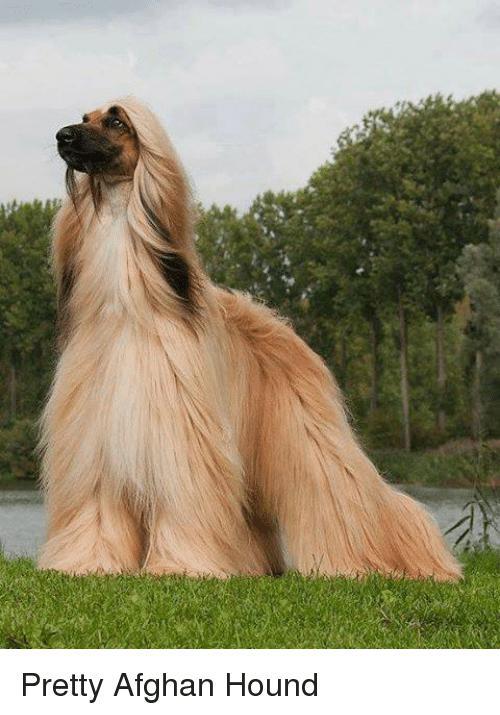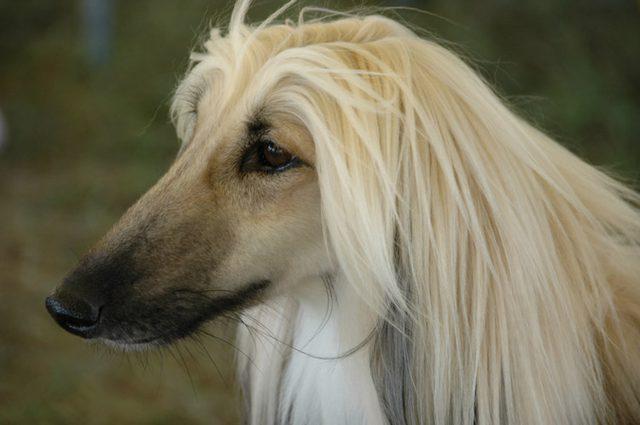The first image is the image on the left, the second image is the image on the right. For the images shown, is this caption "One dog is standing on all fours, and the other dog is reclining with raised head and outstretched front paws on the grass." true? Answer yes or no. No. 